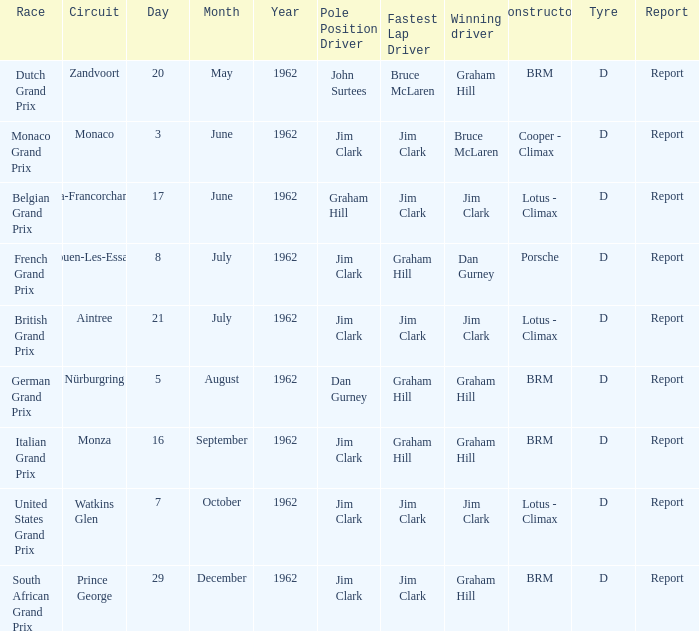What is the date of the circuit of Monaco? 3 June. 